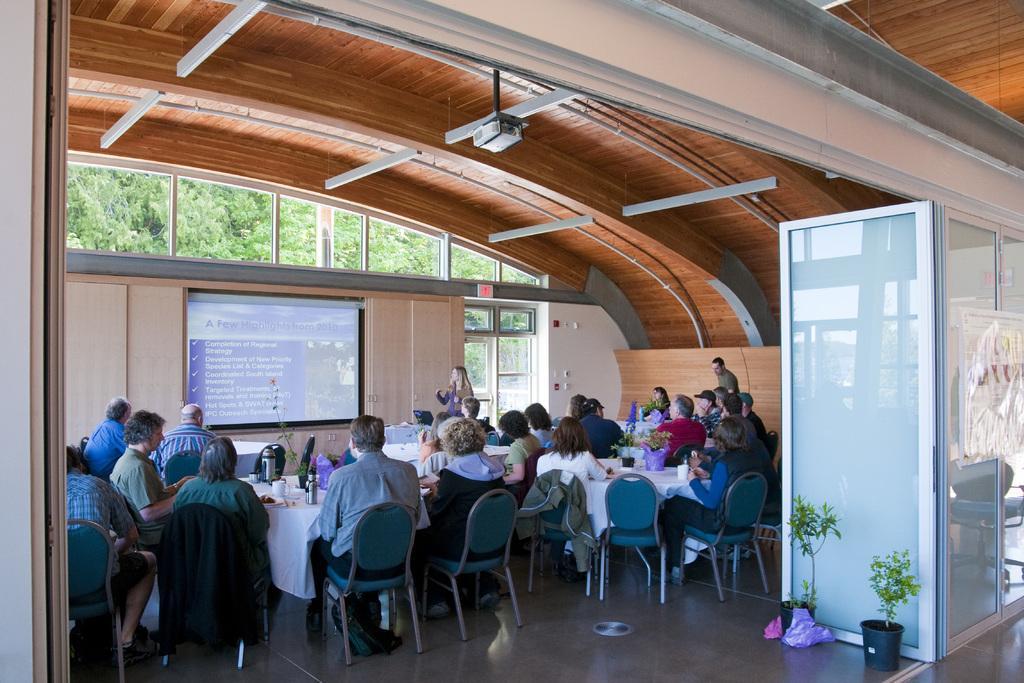In one or two sentences, can you explain what this image depicts? As we can see in the image there are trees, wall, window, screen, pots, few people sitting on chairs and there is a table. On table there are glasses and bottles. 